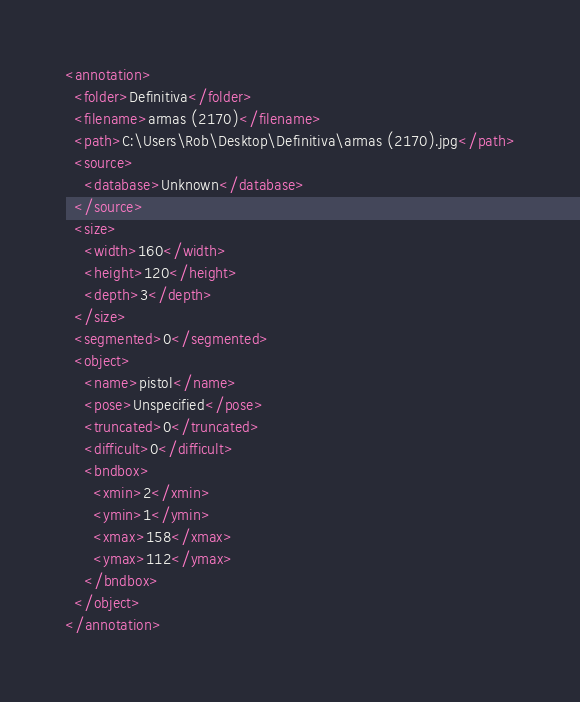Convert code to text. <code><loc_0><loc_0><loc_500><loc_500><_XML_><annotation>
  <folder>Definitiva</folder>
  <filename>armas (2170)</filename>
  <path>C:\Users\Rob\Desktop\Definitiva\armas (2170).jpg</path>
  <source>
    <database>Unknown</database>
  </source>
  <size>
    <width>160</width>
    <height>120</height>
    <depth>3</depth>
  </size>
  <segmented>0</segmented>
  <object>
    <name>pistol</name>
    <pose>Unspecified</pose>
    <truncated>0</truncated>
    <difficult>0</difficult>
    <bndbox>
      <xmin>2</xmin>
      <ymin>1</ymin>
      <xmax>158</xmax>
      <ymax>112</ymax>
    </bndbox>
  </object>
</annotation>
</code> 